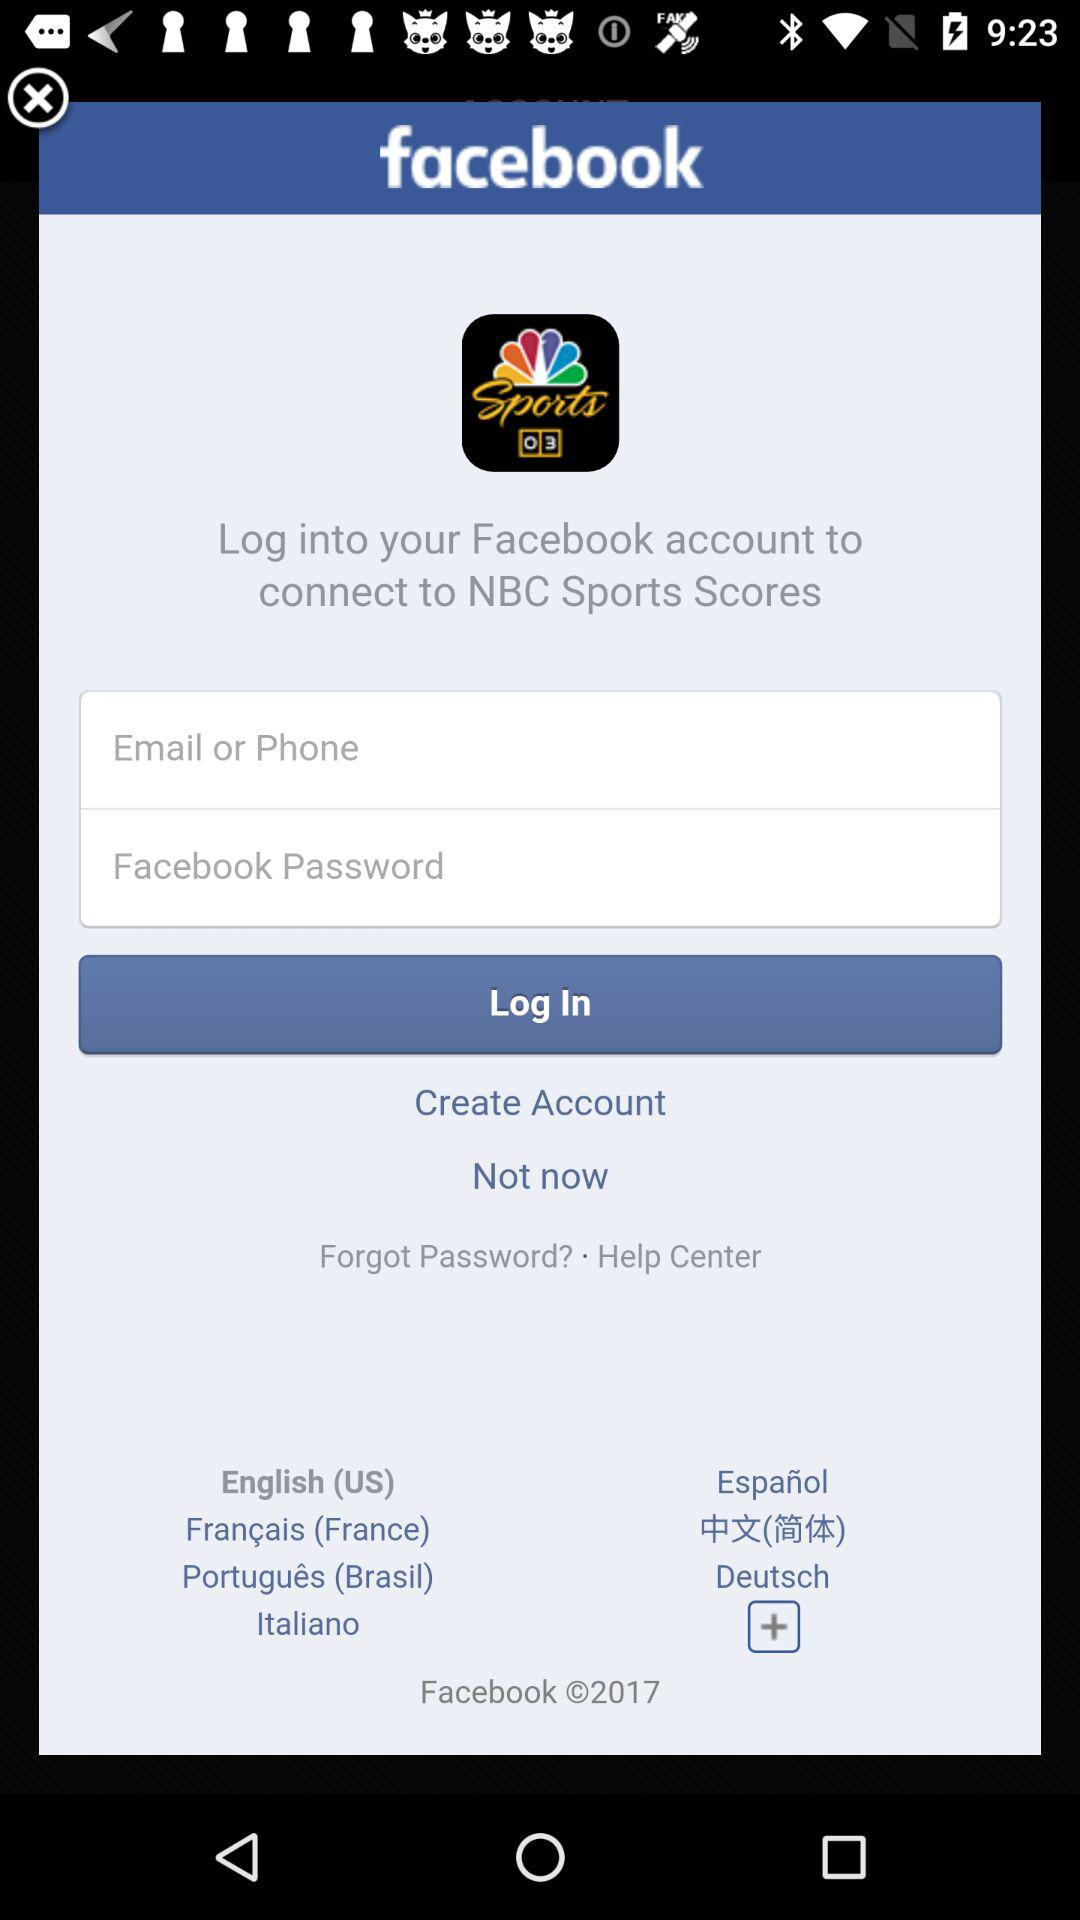Through what application can we login and connect to NBC Sports Scores? We can login with "Facebook". 